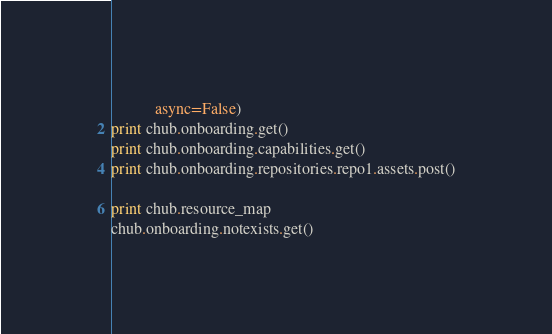Convert code to text. <code><loc_0><loc_0><loc_500><loc_500><_Python_>           async=False)
print chub.onboarding.get()
print chub.onboarding.capabilities.get()
print chub.onboarding.repositories.repo1.assets.post()

print chub.resource_map
chub.onboarding.notexists.get()
</code> 